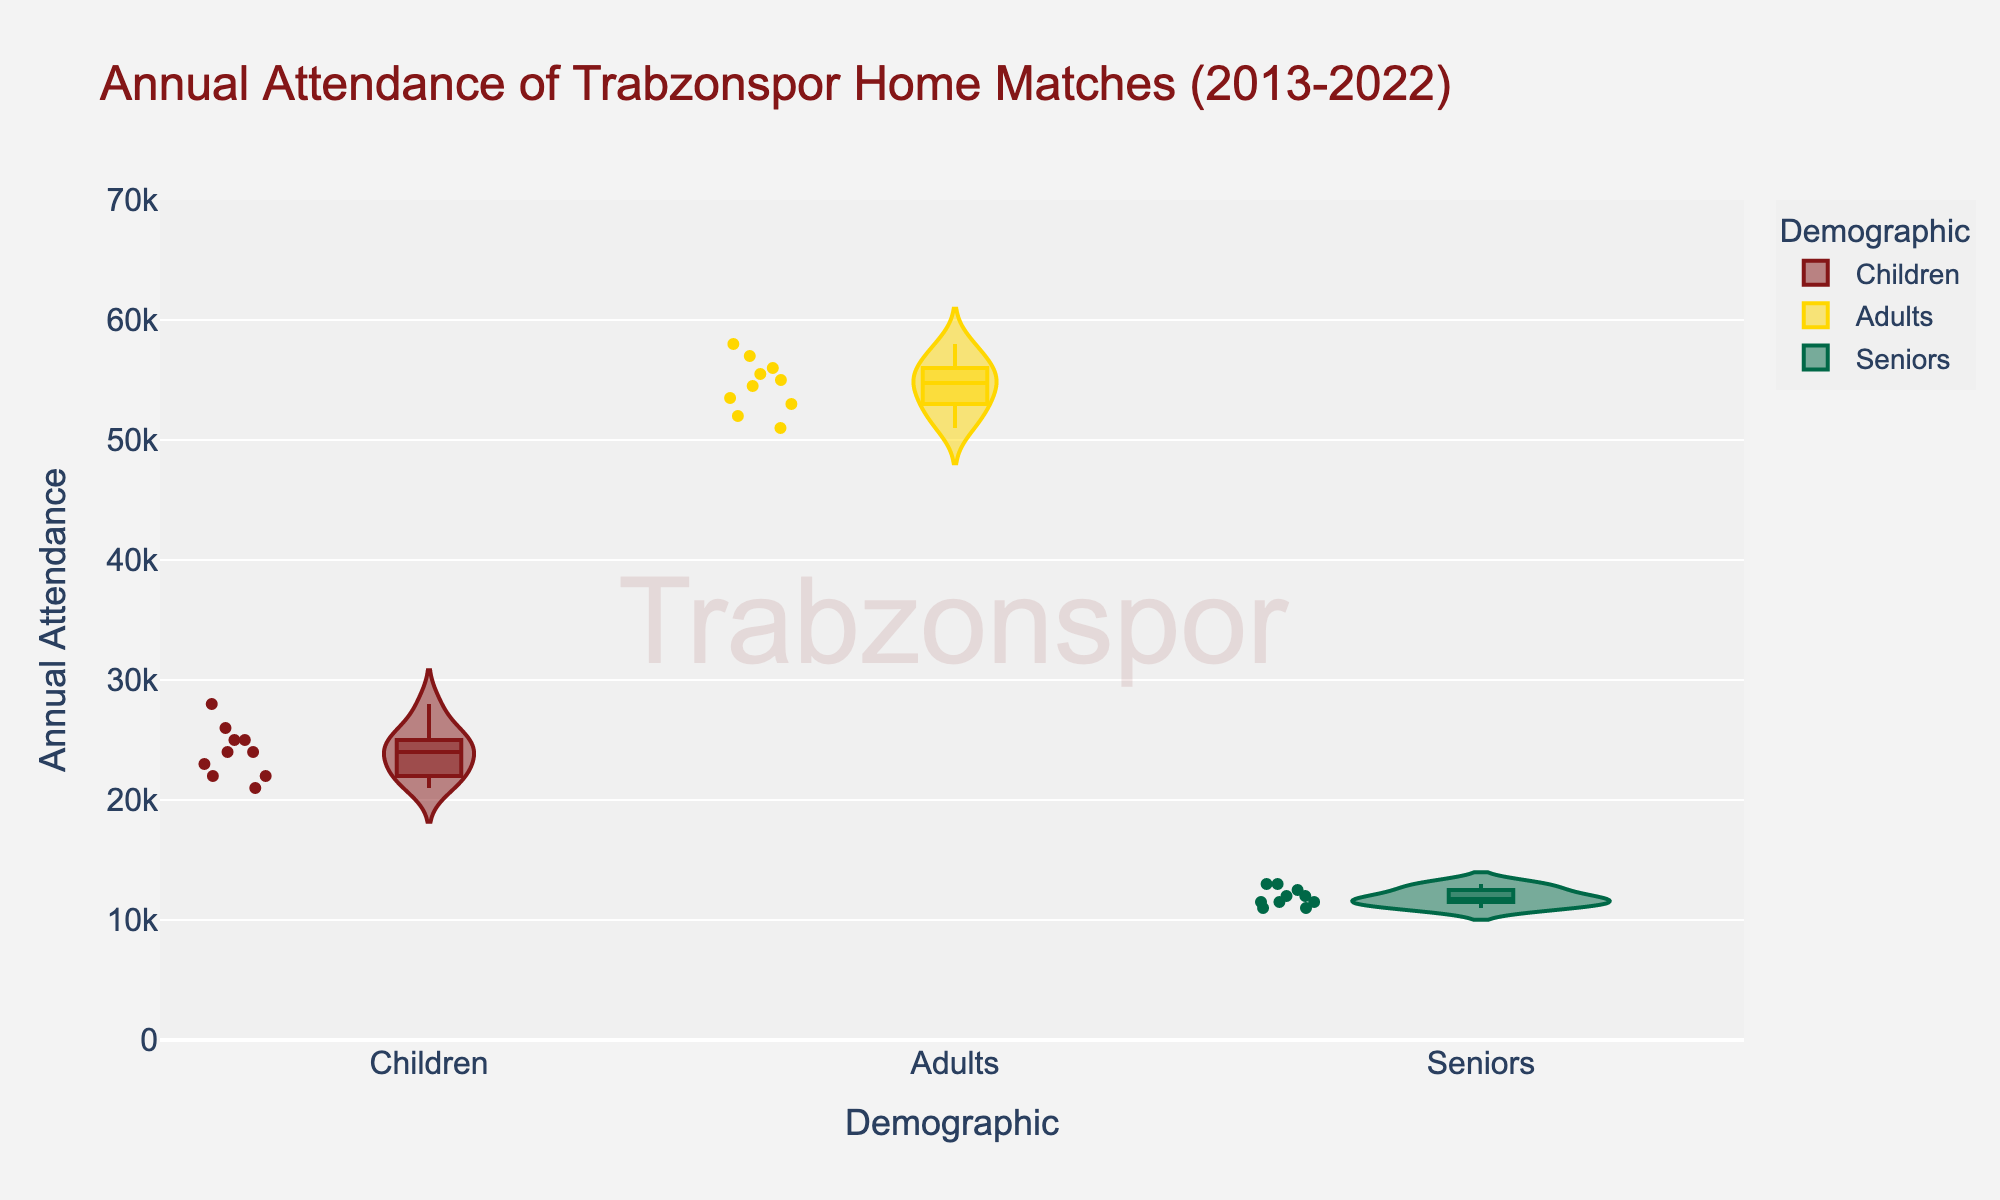what is the title of the figure? The title is typically located at the top center of the figure. It provides an overview of what the figure is about. In this case, the title is "Annual Attendance of Trabzonspor Home Matches (2013-2022)"
Answer: Annual Attendance of Trabzonspor Home Matches (2013-2022) What is the range of attendance for adults? The violin plot's y-axis shows the range of attendance values, and for adults, the range goes from a minimum of around 50000 to a maximum of around 58000.
Answer: 50000 to 58000 For which demographic segment is the median attendance the highest? In a violin plot, the box represents the interquartile range and the median is typically indicated by a line within the box. By visually inspecting the boxes, it is clear that adults have the highest median attendance.
Answer: Adults What can you say about the spread of attendance data for children compared to seniors? A violin plot shows the distribution of the data. By comparing the width of the violins, we can see that children's attendance data has a relatively wider spread, indicating more variability, while seniors have a narrower spread, indicating less variability.
Answer: Children have a wider spread of attendance data than seniors Which demographic group generally has the lowest attendance? By looking at the range of attendance data on the y-axis for each demographic, we see that seniors generally have the lowest attendance compared to children and adults.
Answer: Seniors By how much does the upper limit of children's attendance range differ from that of adults? First, observe the upper limits on the y-axis for children and adults. For children, it is around 28000, and for adults, it is around 58000. The difference is calculated as 58000 - 28000.
Answer: 30000 Are there any outliers in the attendance data for seniors? In a violin plot, outliers are typically shown as individual points outside the box. By inspecting the seniors' segment, we note that there are no such points.
Answer: No What is the average attendance for children over the decade? Although not directly available from the violin plot, the average can be inferred if numerical values are displayed. However, in this plot, one would typically calculate the average based on underlying data. Given the average nature of the plot, we can approximate this by visually estimating the central tendency, which is around 24000-25000 annually.
Answer: About 24000-25000 Which demographic is most consistent in their attendance? Consistency can be inferred by looking at the narrowness of the violin plot’s distribution. Seniors have a relatively narrower distribution, indicating more consistency in attendance.
Answer: Seniors 